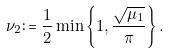<formula> <loc_0><loc_0><loc_500><loc_500>\nu _ { 2 } \colon = \frac { 1 } { 2 } \min \left \{ 1 , \frac { \sqrt { \mu _ { 1 } } } { \pi } \right \} .</formula> 